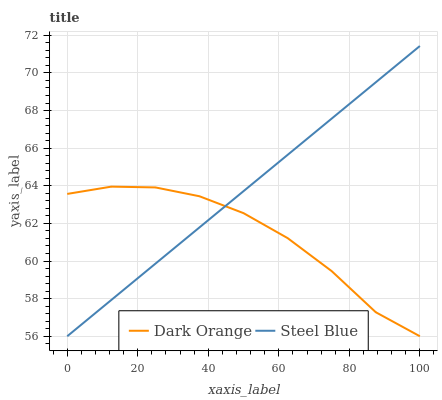Does Dark Orange have the minimum area under the curve?
Answer yes or no. Yes. Does Steel Blue have the maximum area under the curve?
Answer yes or no. Yes. Does Steel Blue have the minimum area under the curve?
Answer yes or no. No. Is Steel Blue the smoothest?
Answer yes or no. Yes. Is Dark Orange the roughest?
Answer yes or no. Yes. Is Steel Blue the roughest?
Answer yes or no. No. Does Dark Orange have the lowest value?
Answer yes or no. Yes. Does Steel Blue have the highest value?
Answer yes or no. Yes. Does Steel Blue intersect Dark Orange?
Answer yes or no. Yes. Is Steel Blue less than Dark Orange?
Answer yes or no. No. Is Steel Blue greater than Dark Orange?
Answer yes or no. No. 